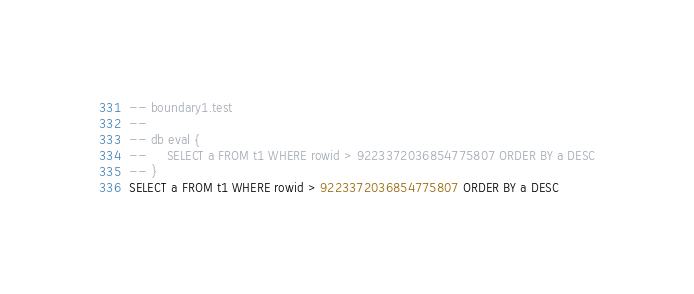Convert code to text. <code><loc_0><loc_0><loc_500><loc_500><_SQL_>-- boundary1.test
-- 
-- db eval {
--     SELECT a FROM t1 WHERE rowid > 9223372036854775807 ORDER BY a DESC
-- }
SELECT a FROM t1 WHERE rowid > 9223372036854775807 ORDER BY a DESC</code> 